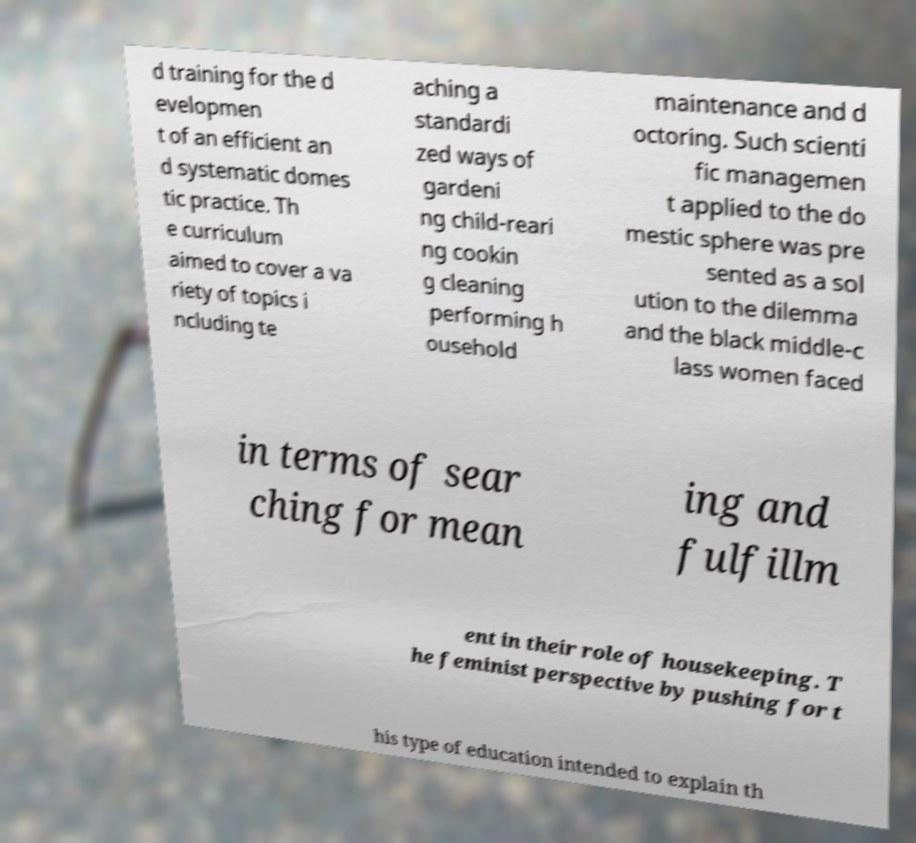Please read and relay the text visible in this image. What does it say? d training for the d evelopmen t of an efficient an d systematic domes tic practice. Th e curriculum aimed to cover a va riety of topics i ncluding te aching a standardi zed ways of gardeni ng child-reari ng cookin g cleaning performing h ousehold maintenance and d octoring. Such scienti fic managemen t applied to the do mestic sphere was pre sented as a sol ution to the dilemma and the black middle-c lass women faced in terms of sear ching for mean ing and fulfillm ent in their role of housekeeping. T he feminist perspective by pushing for t his type of education intended to explain th 